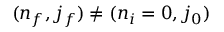<formula> <loc_0><loc_0><loc_500><loc_500>{ ( n _ { f } , j _ { f } ) \neq ( n _ { i } = 0 , j _ { 0 } ) }</formula> 